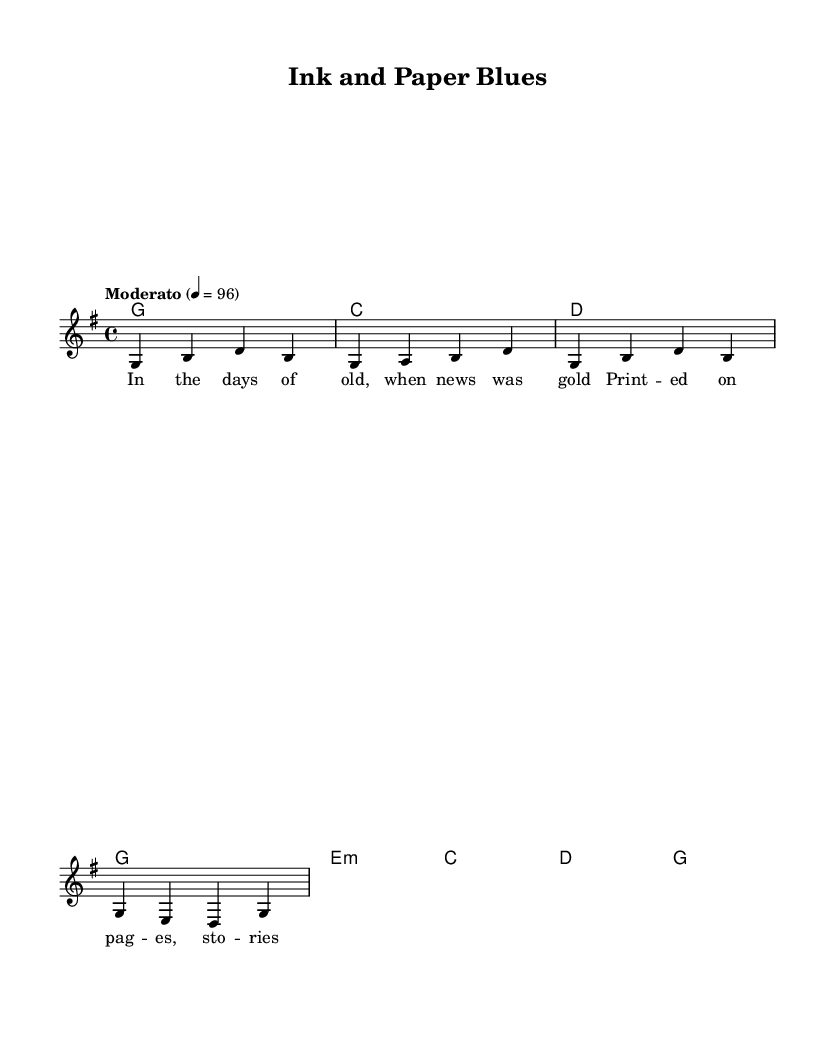What is the key signature of this music? The key signature is G major, which has one sharp (F#).
Answer: G major What is the time signature of this piece? The time signature is 4/4, indicating four beats in each measure.
Answer: 4/4 What is the tempo marking for the song? The tempo is marked as 'Moderato' with a metronome marking of 96 beats per minute.
Answer: Moderato How many measures are there in the melody? The melody consists of four measures as indicated by the grouping.
Answer: Four measures What chords are used in the harmonies section? The chords used are G, C, D, and E minor, which are typical in country music.
Answer: G, C, D, E minor What is the main theme of the lyrics in the first verse? The lyrics reflect on the historical significance of print media and storytelling.
Answer: Historical significance of print media What is the relationship between the melody and lyrics? The lyrics correspond to the melody, with each syllable matched to a note, enhancing the storytelling element.
Answer: Syllable to note correspondence 